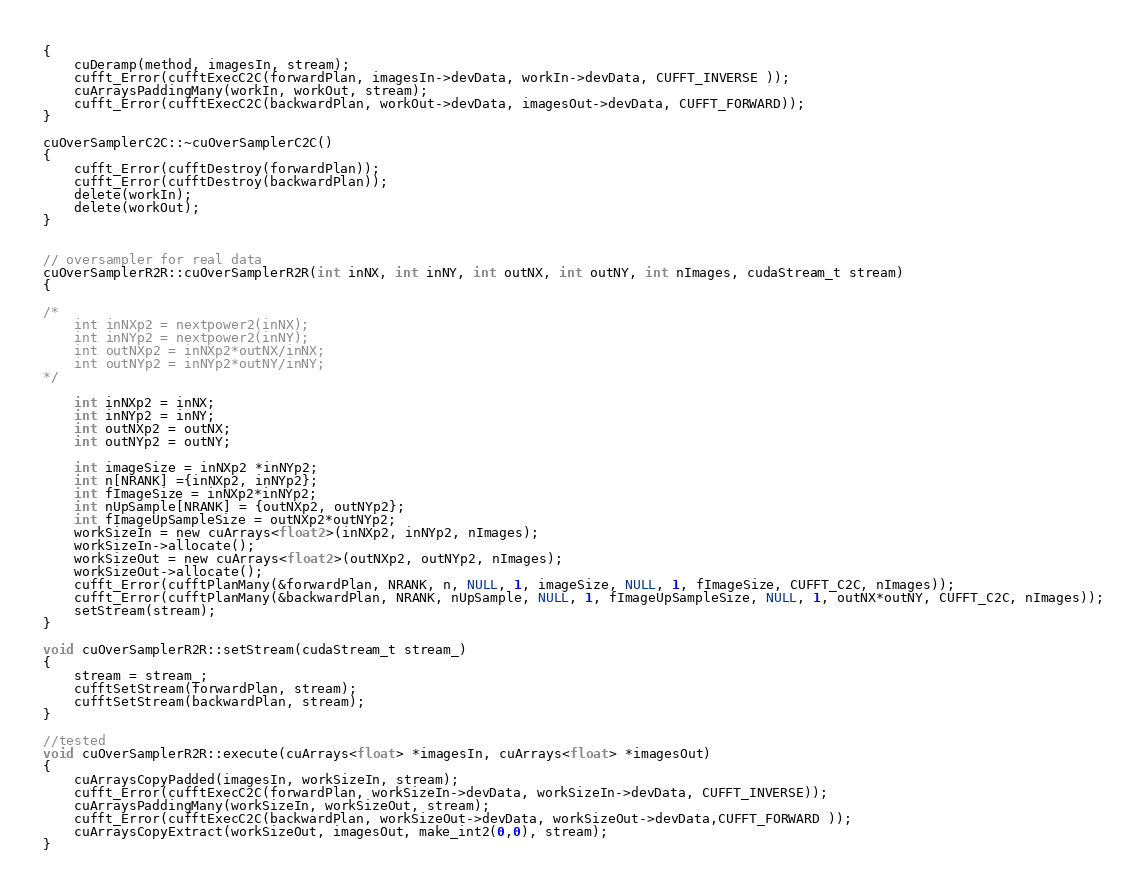<code> <loc_0><loc_0><loc_500><loc_500><_Cuda_>{   
    cuDeramp(method, imagesIn, stream);         
    cufft_Error(cufftExecC2C(forwardPlan, imagesIn->devData, workIn->devData, CUFFT_INVERSE ));
    cuArraysPaddingMany(workIn, workOut, stream);
    cufft_Error(cufftExecC2C(backwardPlan, workOut->devData, imagesOut->devData, CUFFT_FORWARD));
}

cuOverSamplerC2C::~cuOverSamplerC2C() 
{
    cufft_Error(cufftDestroy(forwardPlan));
    cufft_Error(cufftDestroy(backwardPlan));
    delete(workIn);
    delete(workOut);	
}


// oversampler for real data
cuOverSamplerR2R::cuOverSamplerR2R(int inNX, int inNY, int outNX, int outNY, int nImages, cudaStream_t stream)
{
    
/*    
    int inNXp2 = nextpower2(inNX);
    int inNYp2 = nextpower2(inNY);
    int outNXp2 = inNXp2*outNX/inNX;
    int outNYp2 = inNYp2*outNY/inNY;    
*/
    
    int inNXp2 = inNX;
    int inNYp2 = inNY;
    int outNXp2 = outNX;
    int outNYp2 = outNY;

    int imageSize = inNXp2 *inNYp2;
    int n[NRANK] ={inNXp2, inNYp2};
    int fImageSize = inNXp2*inNYp2;
    int nUpSample[NRANK] = {outNXp2, outNYp2};
    int fImageUpSampleSize = outNXp2*outNYp2;
    workSizeIn = new cuArrays<float2>(inNXp2, inNYp2, nImages);
    workSizeIn->allocate();
    workSizeOut = new cuArrays<float2>(outNXp2, outNYp2, nImages);
    workSizeOut->allocate();
    cufft_Error(cufftPlanMany(&forwardPlan, NRANK, n, NULL, 1, imageSize, NULL, 1, fImageSize, CUFFT_C2C, nImages));
    cufft_Error(cufftPlanMany(&backwardPlan, NRANK, nUpSample, NULL, 1, fImageUpSampleSize, NULL, 1, outNX*outNY, CUFFT_C2C, nImages));
    setStream(stream);
}

void cuOverSamplerR2R::setStream(cudaStream_t stream_)
{
    stream = stream_;
    cufftSetStream(forwardPlan, stream);
    cufftSetStream(backwardPlan, stream);
}

//tested
void cuOverSamplerR2R::execute(cuArrays<float> *imagesIn, cuArrays<float> *imagesOut)
{
    cuArraysCopyPadded(imagesIn, workSizeIn, stream);
    cufft_Error(cufftExecC2C(forwardPlan, workSizeIn->devData, workSizeIn->devData, CUFFT_INVERSE));
    cuArraysPaddingMany(workSizeIn, workSizeOut, stream);
    cufft_Error(cufftExecC2C(backwardPlan, workSizeOut->devData, workSizeOut->devData,CUFFT_FORWARD ));
    cuArraysCopyExtract(workSizeOut, imagesOut, make_int2(0,0), stream);	
}
</code> 